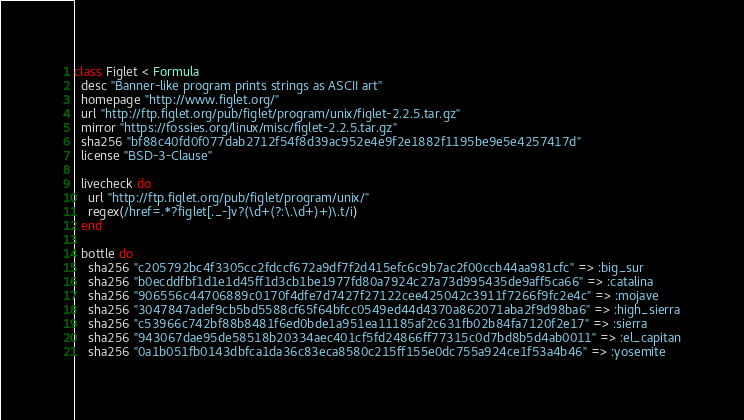Convert code to text. <code><loc_0><loc_0><loc_500><loc_500><_Ruby_>class Figlet < Formula
  desc "Banner-like program prints strings as ASCII art"
  homepage "http://www.figlet.org/"
  url "http://ftp.figlet.org/pub/figlet/program/unix/figlet-2.2.5.tar.gz"
  mirror "https://fossies.org/linux/misc/figlet-2.2.5.tar.gz"
  sha256 "bf88c40fd0f077dab2712f54f8d39ac952e4e9f2e1882f1195be9e5e4257417d"
  license "BSD-3-Clause"

  livecheck do
    url "http://ftp.figlet.org/pub/figlet/program/unix/"
    regex(/href=.*?figlet[._-]v?(\d+(?:\.\d+)+)\.t/i)
  end

  bottle do
    sha256 "c205792bc4f3305cc2fdccf672a9df7f2d415efc6c9b7ac2f00ccb44aa981cfc" => :big_sur
    sha256 "b0ecddfbf1d1e1d45ff1d3cb1be1977fd80a7924c27a73d995435de9aff5ca66" => :catalina
    sha256 "906556c44706889c0170f4dfe7d7427f27122cee425042c3911f7266f9fc2e4c" => :mojave
    sha256 "3047847adef9cb5bd5588cf65f64bfcc0549ed44d4370a862071aba2f9d98ba6" => :high_sierra
    sha256 "c53966c742bf88b8481f6ed0bde1a951ea11185af2c631fb02b84fa7120f2e17" => :sierra
    sha256 "943067dae95de58518b20334aec401cf5fd24866ff77315c0d7bd8b5d4ab0011" => :el_capitan
    sha256 "0a1b051fb0143dbfca1da36c83eca8580c215ff155e0dc755a924ce1f53a4b46" => :yosemite</code> 